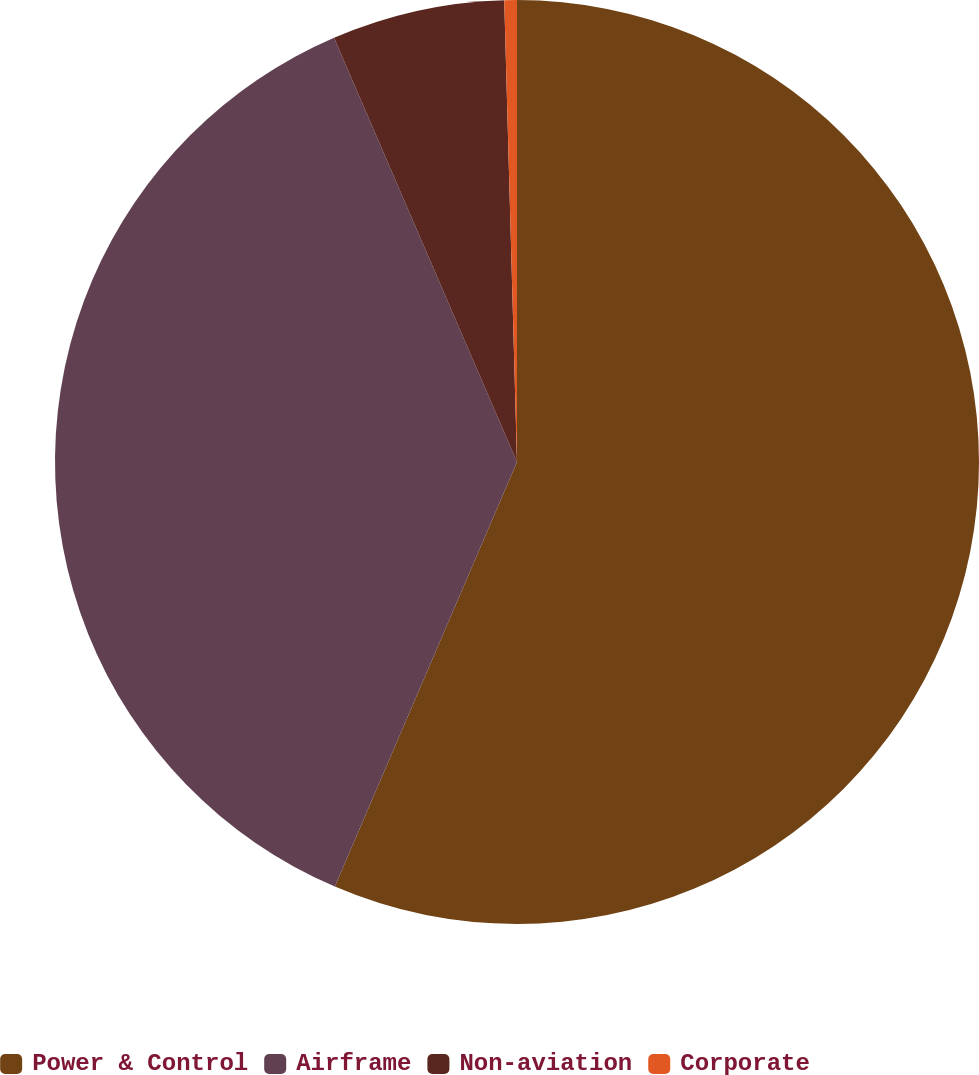Convert chart to OTSL. <chart><loc_0><loc_0><loc_500><loc_500><pie_chart><fcel>Power & Control<fcel>Airframe<fcel>Non-aviation<fcel>Corporate<nl><fcel>56.45%<fcel>37.07%<fcel>6.04%<fcel>0.44%<nl></chart> 